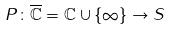<formula> <loc_0><loc_0><loc_500><loc_500>P \colon \overline { \mathbb { C } } = \mathbb { C } \cup \{ \infty \} \rightarrow S</formula> 